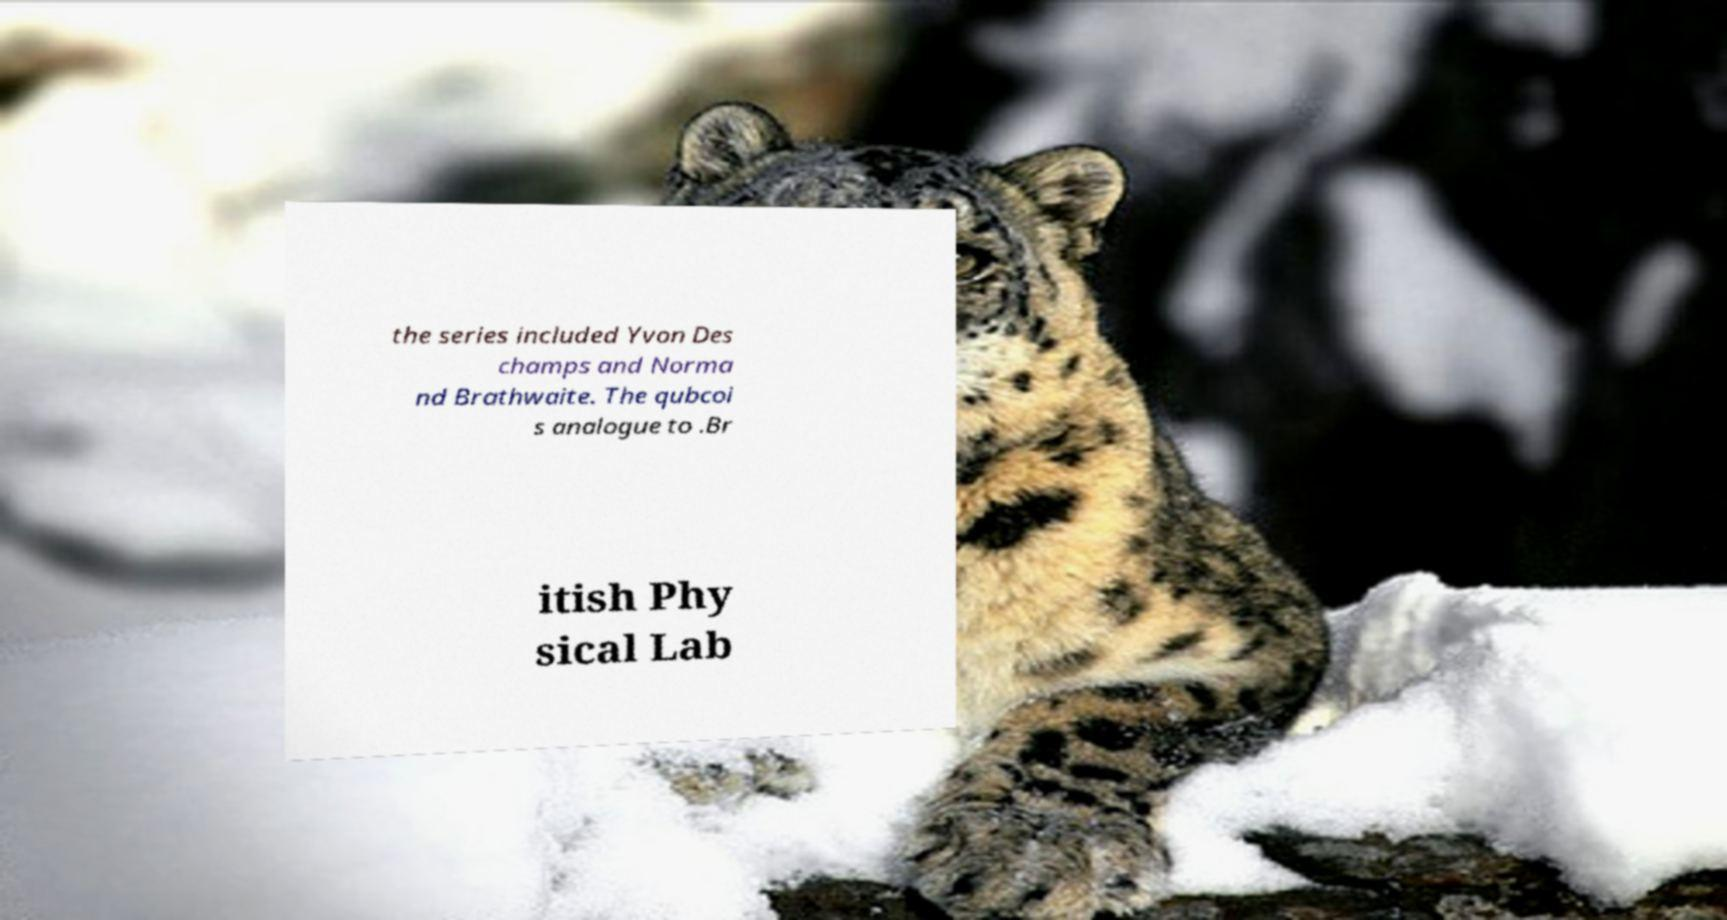Please identify and transcribe the text found in this image. the series included Yvon Des champs and Norma nd Brathwaite. The qubcoi s analogue to .Br itish Phy sical Lab 